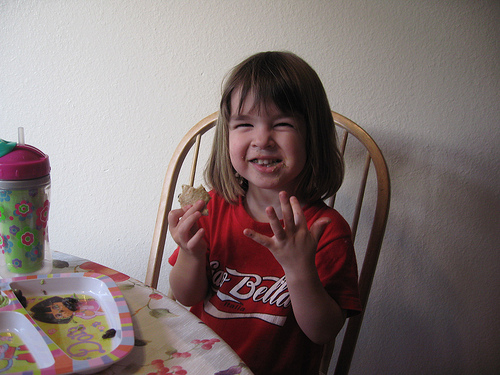<image>
Is the food in front of the plate? Yes. The food is positioned in front of the plate, appearing closer to the camera viewpoint. 